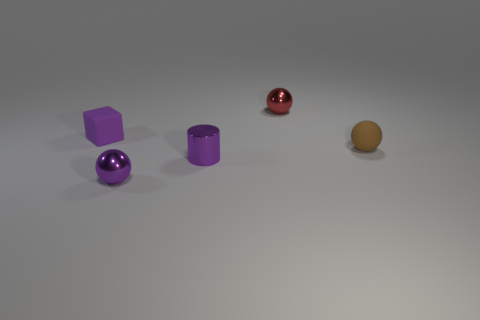Add 3 big cyan balls. How many objects exist? 8 Subtract all spheres. How many objects are left? 2 Add 3 small shiny cylinders. How many small shiny cylinders exist? 4 Subtract 0 brown blocks. How many objects are left? 5 Subtract all brown objects. Subtract all purple balls. How many objects are left? 3 Add 3 purple matte cubes. How many purple matte cubes are left? 4 